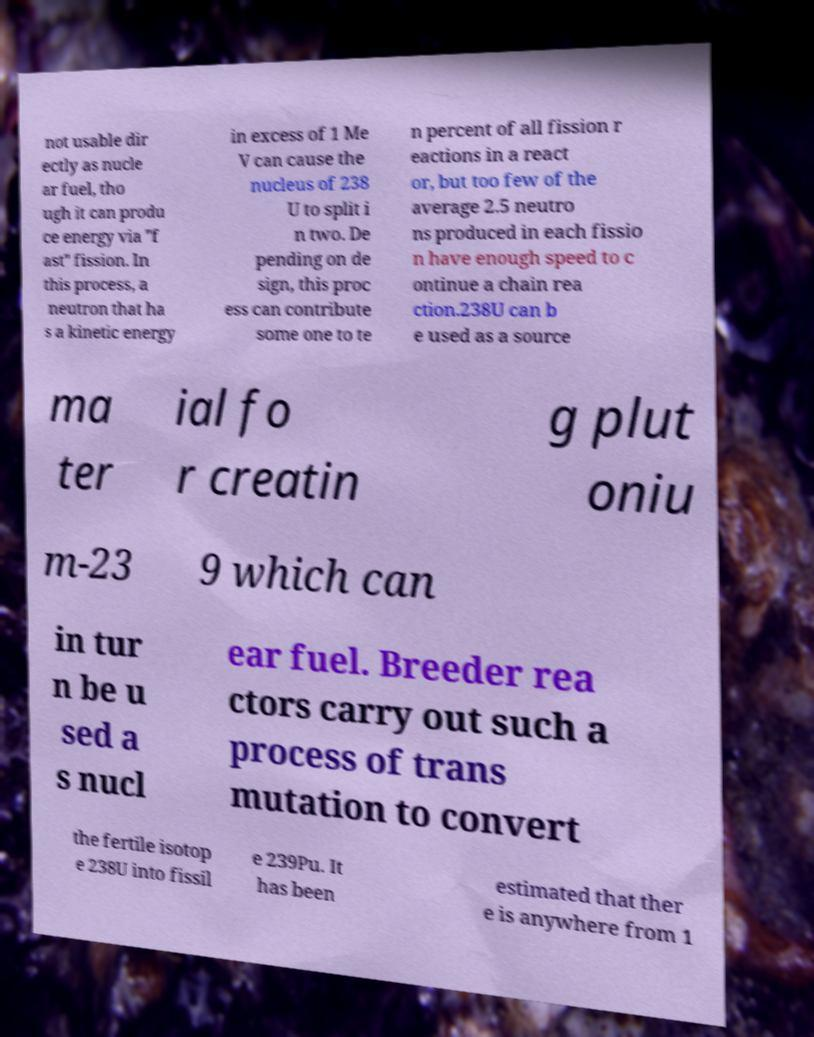Could you assist in decoding the text presented in this image and type it out clearly? not usable dir ectly as nucle ar fuel, tho ugh it can produ ce energy via "f ast" fission. In this process, a neutron that ha s a kinetic energy in excess of 1 Me V can cause the nucleus of 238 U to split i n two. De pending on de sign, this proc ess can contribute some one to te n percent of all fission r eactions in a react or, but too few of the average 2.5 neutro ns produced in each fissio n have enough speed to c ontinue a chain rea ction.238U can b e used as a source ma ter ial fo r creatin g plut oniu m-23 9 which can in tur n be u sed a s nucl ear fuel. Breeder rea ctors carry out such a process of trans mutation to convert the fertile isotop e 238U into fissil e 239Pu. It has been estimated that ther e is anywhere from 1 